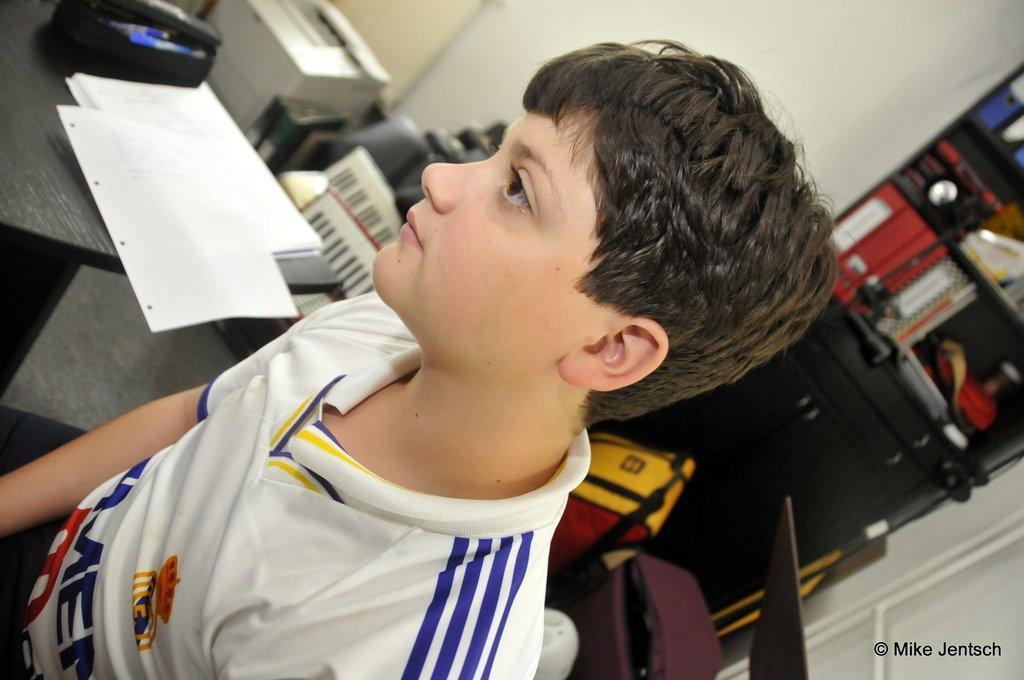Describe this image in one or two sentences. In the picture I can see a person wearing white color T-shirt is here. The background of the image is slightly blurred, where we can see papers and few more objects are placed on the table, we can see pianos, printer, few objects kept in the cupboard. Here I can see the watermark at the bottom right side of the image. 